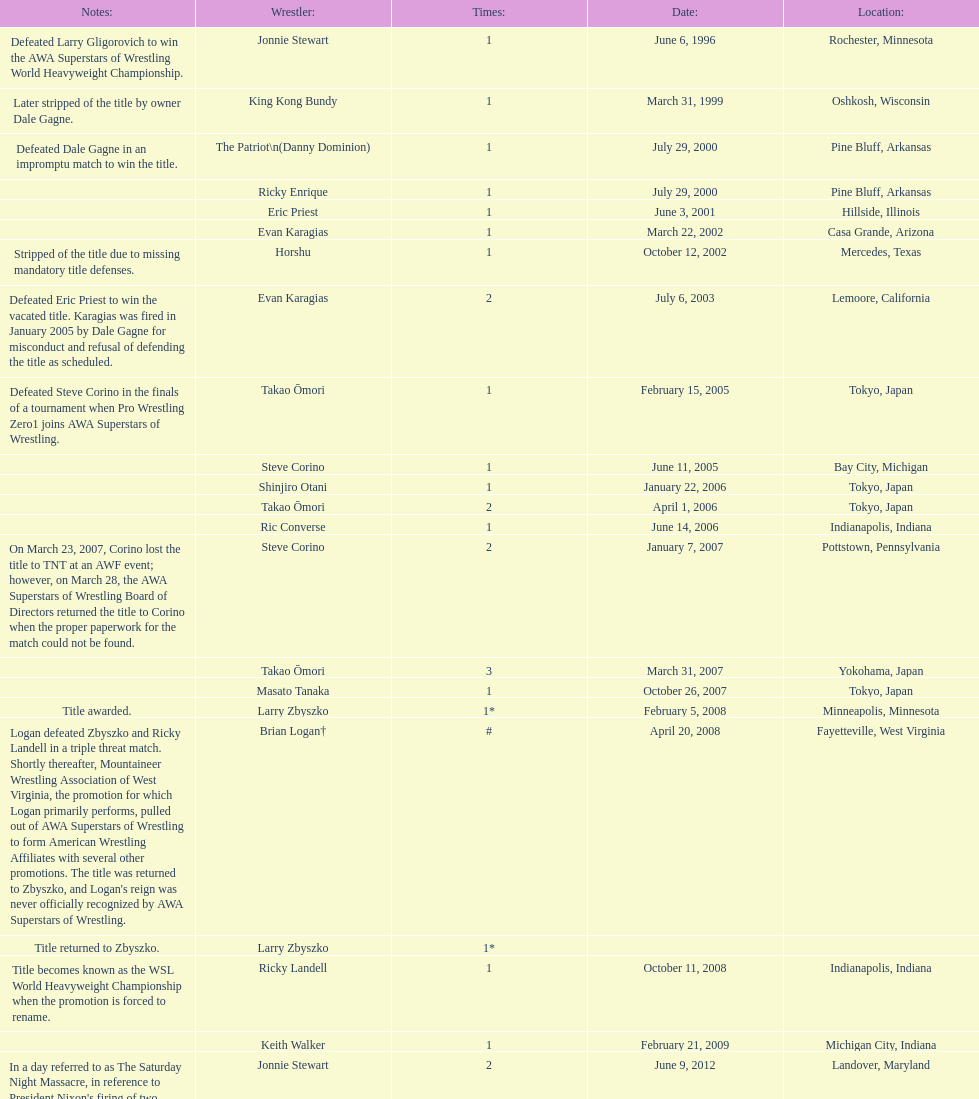When did steve corino win his first wsl title? June 11, 2005. Help me parse the entirety of this table. {'header': ['Notes:', 'Wrestler:', 'Times:', 'Date:', 'Location:'], 'rows': [['Defeated Larry Gligorovich to win the AWA Superstars of Wrestling World Heavyweight Championship.', 'Jonnie Stewart', '1', 'June 6, 1996', 'Rochester, Minnesota'], ['Later stripped of the title by owner Dale Gagne.', 'King Kong Bundy', '1', 'March 31, 1999', 'Oshkosh, Wisconsin'], ['Defeated Dale Gagne in an impromptu match to win the title.', 'The Patriot\\n(Danny Dominion)', '1', 'July 29, 2000', 'Pine Bluff, Arkansas'], ['', 'Ricky Enrique', '1', 'July 29, 2000', 'Pine Bluff, Arkansas'], ['', 'Eric Priest', '1', 'June 3, 2001', 'Hillside, Illinois'], ['', 'Evan Karagias', '1', 'March 22, 2002', 'Casa Grande, Arizona'], ['Stripped of the title due to missing mandatory title defenses.', 'Horshu', '1', 'October 12, 2002', 'Mercedes, Texas'], ['Defeated Eric Priest to win the vacated title. Karagias was fired in January 2005 by Dale Gagne for misconduct and refusal of defending the title as scheduled.', 'Evan Karagias', '2', 'July 6, 2003', 'Lemoore, California'], ['Defeated Steve Corino in the finals of a tournament when Pro Wrestling Zero1 joins AWA Superstars of Wrestling.', 'Takao Ōmori', '1', 'February 15, 2005', 'Tokyo, Japan'], ['', 'Steve Corino', '1', 'June 11, 2005', 'Bay City, Michigan'], ['', 'Shinjiro Otani', '1', 'January 22, 2006', 'Tokyo, Japan'], ['', 'Takao Ōmori', '2', 'April 1, 2006', 'Tokyo, Japan'], ['', 'Ric Converse', '1', 'June 14, 2006', 'Indianapolis, Indiana'], ['On March 23, 2007, Corino lost the title to TNT at an AWF event; however, on March 28, the AWA Superstars of Wrestling Board of Directors returned the title to Corino when the proper paperwork for the match could not be found.', 'Steve Corino', '2', 'January 7, 2007', 'Pottstown, Pennsylvania'], ['', 'Takao Ōmori', '3', 'March 31, 2007', 'Yokohama, Japan'], ['', 'Masato Tanaka', '1', 'October 26, 2007', 'Tokyo, Japan'], ['Title awarded.', 'Larry Zbyszko', '1*', 'February 5, 2008', 'Minneapolis, Minnesota'], ["Logan defeated Zbyszko and Ricky Landell in a triple threat match. Shortly thereafter, Mountaineer Wrestling Association of West Virginia, the promotion for which Logan primarily performs, pulled out of AWA Superstars of Wrestling to form American Wrestling Affiliates with several other promotions. The title was returned to Zbyszko, and Logan's reign was never officially recognized by AWA Superstars of Wrestling.", 'Brian Logan†', '#', 'April 20, 2008', 'Fayetteville, West Virginia'], ['Title returned to Zbyszko.', 'Larry Zbyszko', '1*', '', ''], ['Title becomes known as the WSL World Heavyweight Championship when the promotion is forced to rename.', 'Ricky Landell', '1', 'October 11, 2008', 'Indianapolis, Indiana'], ['', 'Keith Walker', '1', 'February 21, 2009', 'Michigan City, Indiana'], ["In a day referred to as The Saturday Night Massacre, in reference to President Nixon's firing of two Whitehouse attorneys general in one night; President Dale Gagne strips and fires Keith Walker when Walker refuses to defend the title against Ricky Landell, in an event in Landover, Maryland. When Landell is awarded the title, he refuses to accept and is too promptly fired by Gagne, who than awards the title to Jonnie Stewart.", 'Jonnie Stewart', '2', 'June 9, 2012', 'Landover, Maryland'], ["The morning of the event, Jonnie Stewart's doctors declare him PUP (physically unable to perform) and WSL officials agree to let Mike Bally sub for Stewart.", 'The Honky Tonk Man', '1', 'August 18, 2012', 'Rockford, Illinois']]} 